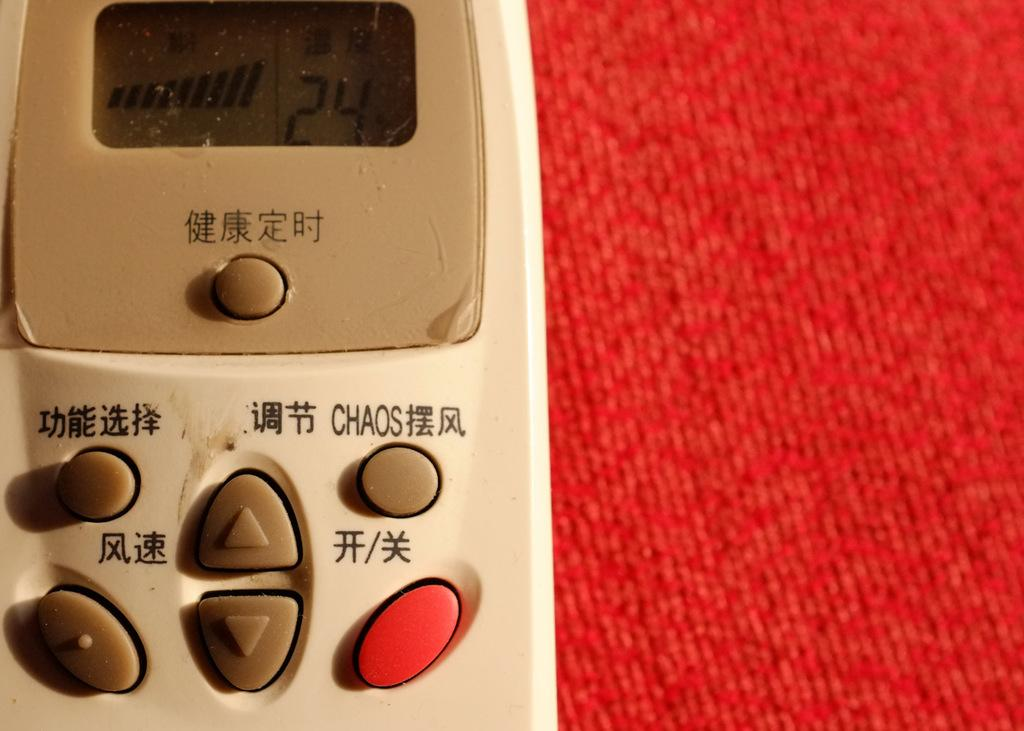<image>
Render a clear and concise summary of the photo. The chaos button can be found directly above the red button on the remote control. 